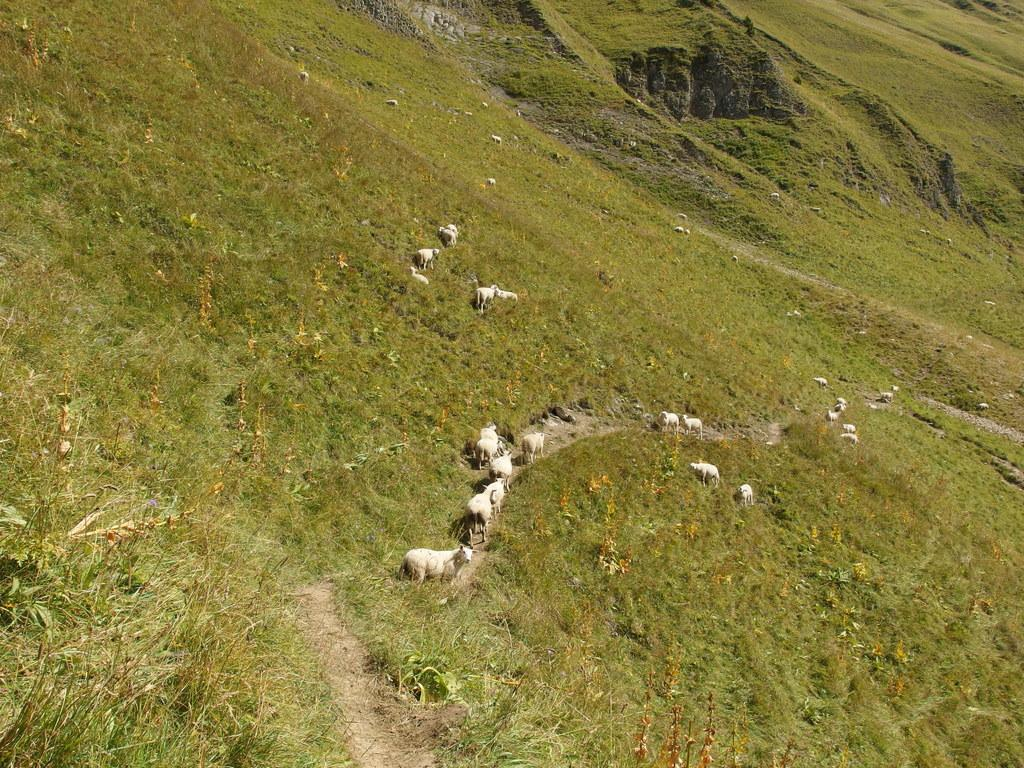What type of vegetation can be seen in the image? There are plants and grass in the image. What kind of path is present in the image? There is a walkway in the image. What other living creatures are visible in the image? There are animals in the image. What type of stocking is being used as bait for the beast in the image? There is no stocking, beast, or bait present in the image. 